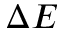Convert formula to latex. <formula><loc_0><loc_0><loc_500><loc_500>\Delta E</formula> 